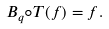Convert formula to latex. <formula><loc_0><loc_0><loc_500><loc_500>B _ { q } \circ T ( f ) = f .</formula> 